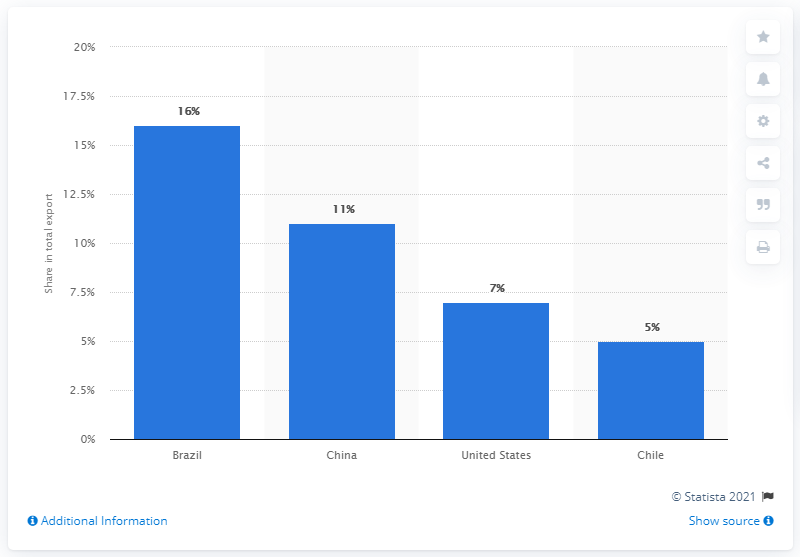Highlight a few significant elements in this photo. Argentina's main export partner in 2019 was Brazil. In 2019, Brazil was Argentina's primary export partner, accounting for the majority of the country's outbound trade. 